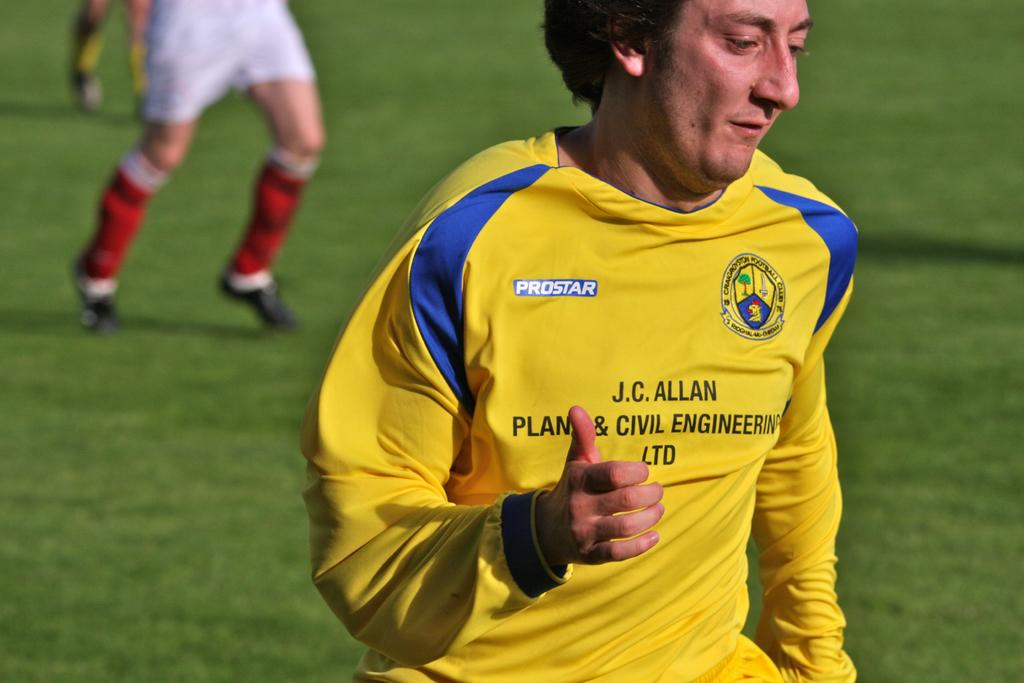Provide a one-sentence caption for the provided image. the soccer player j c allan is doing a thumbs up motion at the camera. 